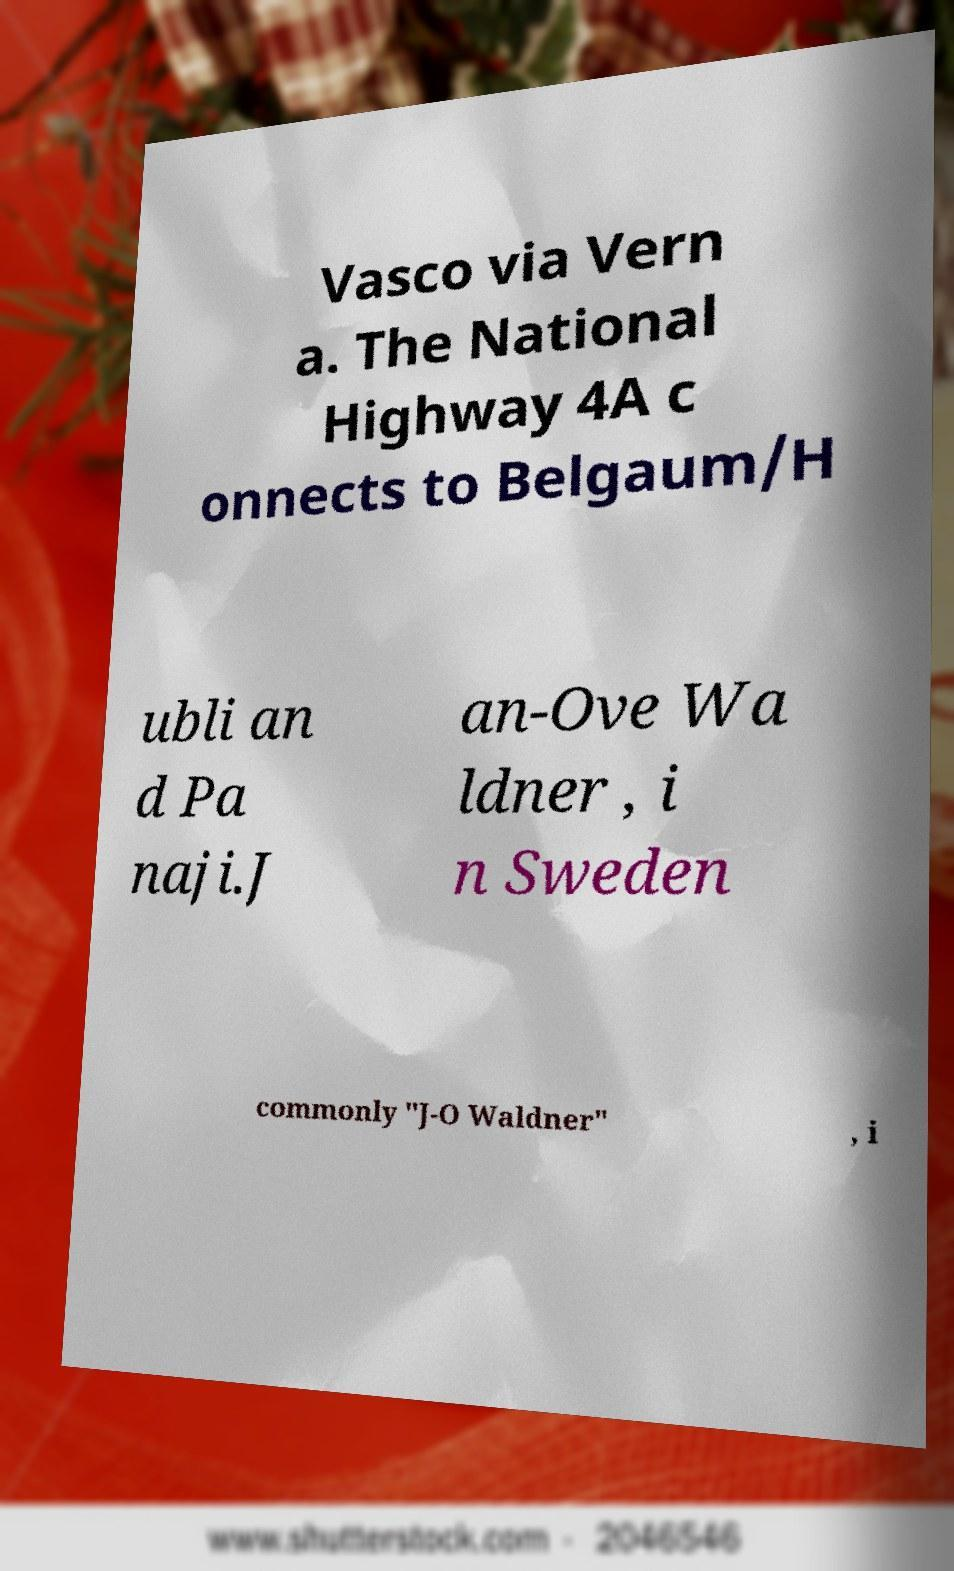What messages or text are displayed in this image? I need them in a readable, typed format. Vasco via Vern a. The National Highway 4A c onnects to Belgaum/H ubli an d Pa naji.J an-Ove Wa ldner , i n Sweden commonly "J-O Waldner" , i 